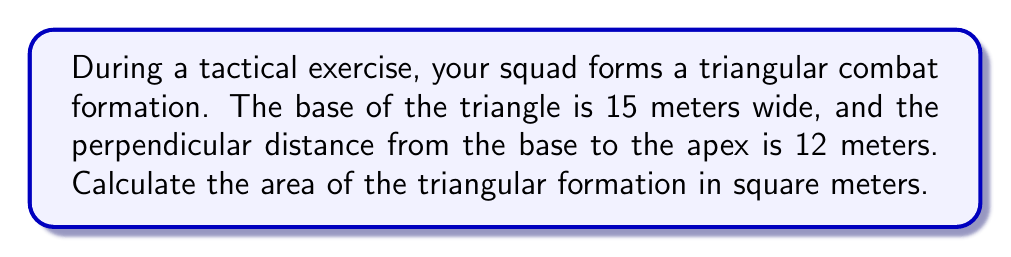Could you help me with this problem? Let's approach this step-by-step:

1) The formula for the area of a triangle is:

   $$A = \frac{1}{2} \times b \times h$$

   Where $A$ is the area, $b$ is the base, and $h$ is the height (perpendicular distance from the base to the apex).

2) We are given:
   - Base (b) = 15 meters
   - Height (h) = 12 meters

3) Let's substitute these values into our formula:

   $$A = \frac{1}{2} \times 15 \times 12$$

4) Now, let's calculate:

   $$A = \frac{1}{2} \times 180$$
   $$A = 90$$

5) Therefore, the area of the triangular formation is 90 square meters.

[asy]
unitsize(0.2cm);
pair A = (0,0), B = (15,0), C = (7.5,12);
draw(A--B--C--cycle);
draw(C--(7.5,0),dashed);
label("15 m", (7.5,-1), S);
label("12 m", (8.5,6), E);
label("A", A, SW);
label("B", B, SE);
label("C", C, N);
[/asy]
Answer: 90 m² 